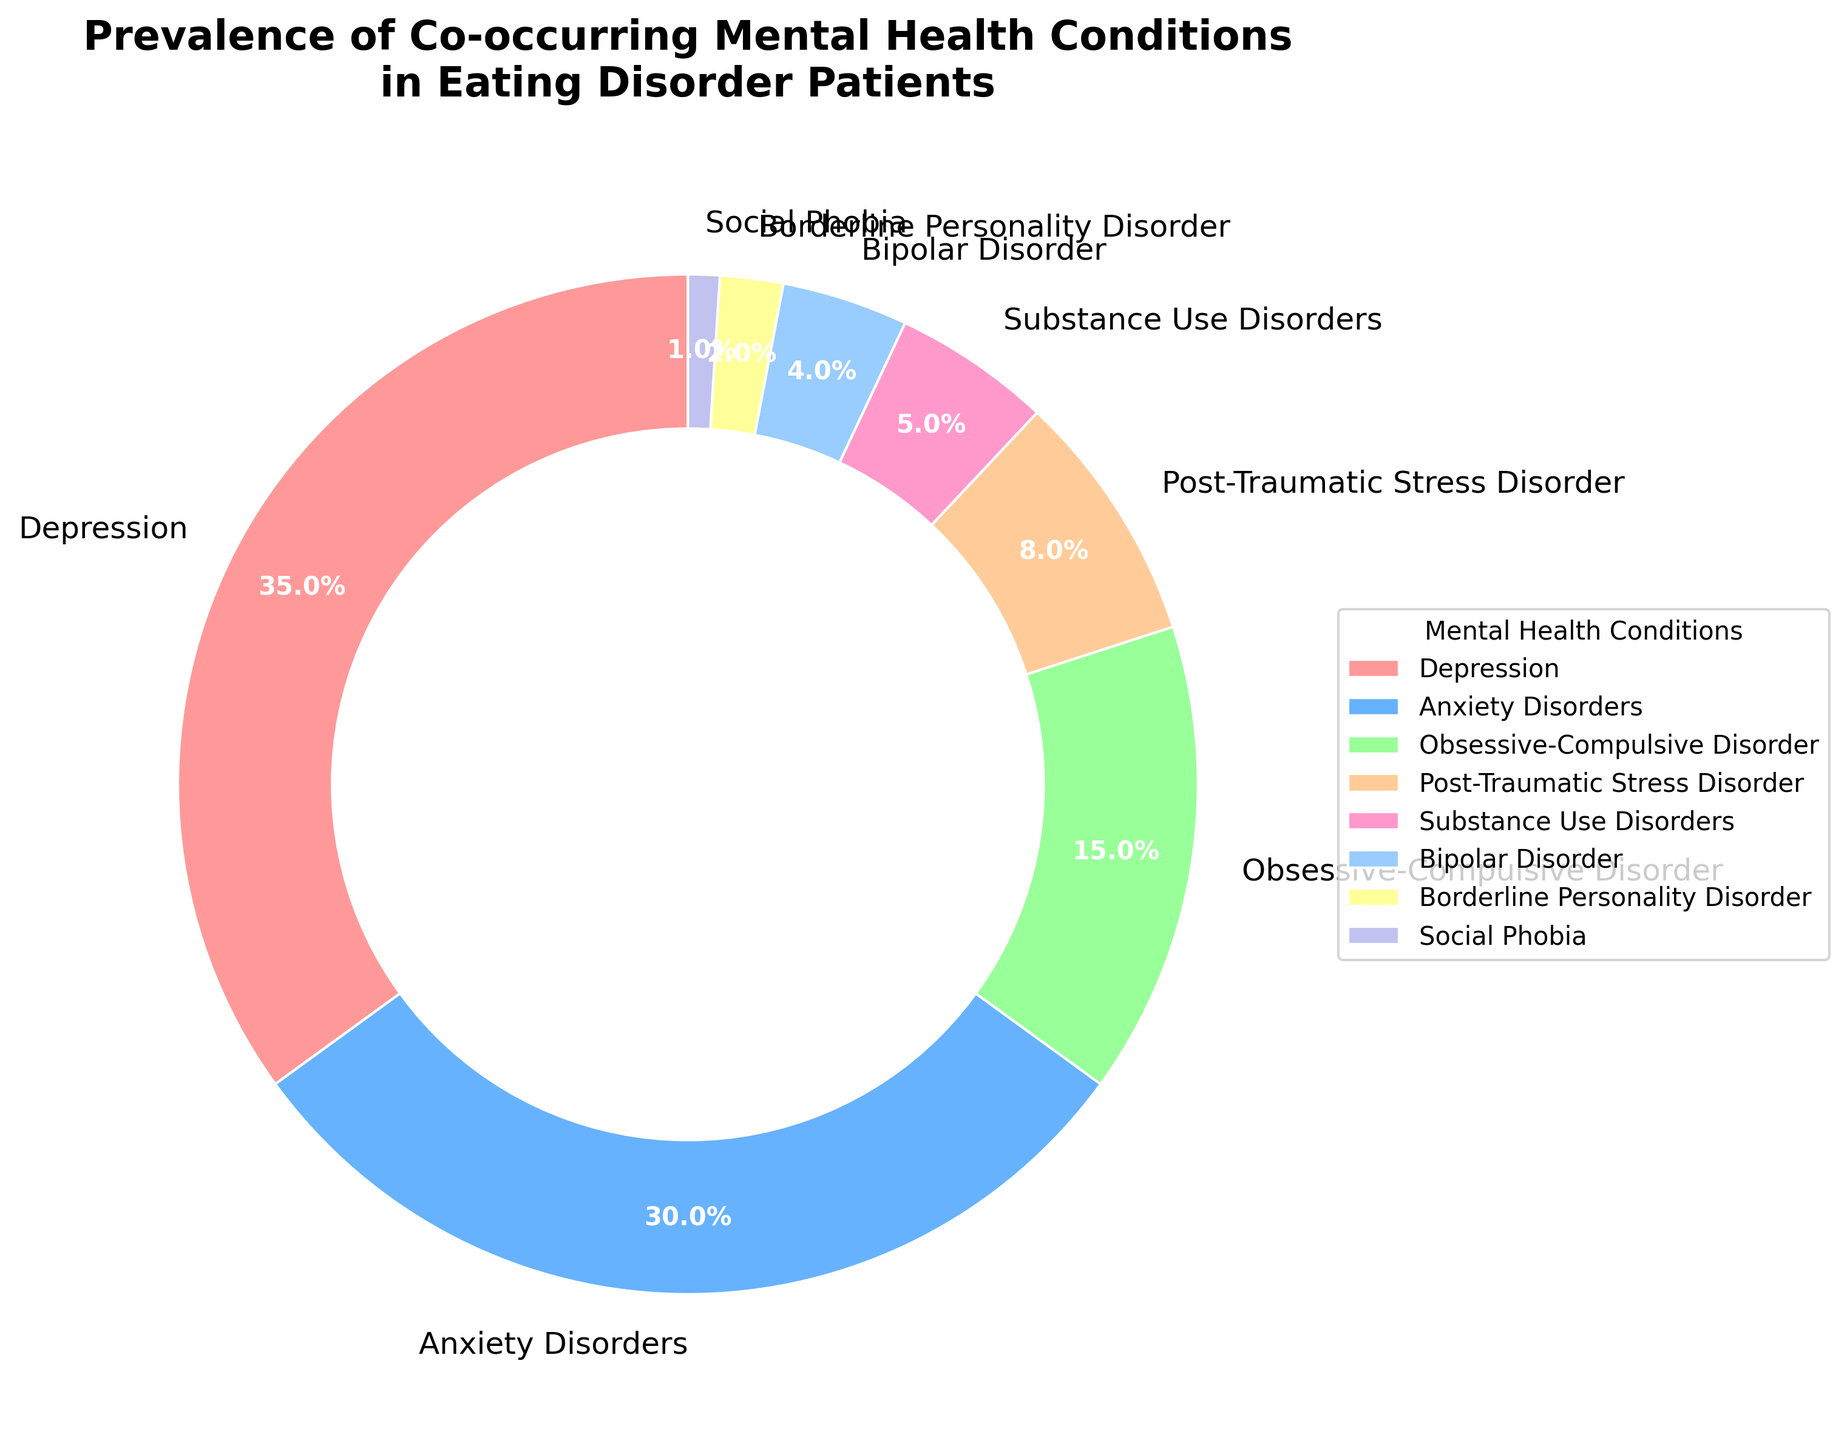What's the most prevalent co-occurring mental health condition among eating disorder patients? The pie chart shows different segments for various mental health conditions. The largest segment represents the most prevalent condition.
Answer: Depression Which mental health disorder has a prevalence percentage twice that of Substance Use Disorders? The pie chart shows various segments with their respective percentages. Substance Use Disorders have a 5% prevalence. A condition with twice this percentage would be 10%. The segment with a 15% prevalence (Obsessive-Compulsive Disorder) is three times, not twice. The closest match is Anxiety Disorders with 30%, but it's not exactly twice 5%.
Answer: None What’s the combined prevalence of Depression and Anxiety Disorders among eating disorder patients? Sum the percentages of Depression (35%) and Anxiety Disorders (30%) by adding them together: 35 + 30.
Answer: 65% Which condition has a prevalence closest to that of Post-Traumatic Stress Disorder? Post-Traumatic Stress Disorder has an 8% prevalence. The closest other percentage in the pie chart is Substance Use Disorders at 5%.
Answer: Substance Use Disorders How does the prevalence of Borderline Personality Disorder compare to Bipolar Disorder? Borderline Personality Disorder has a 2% prevalence, and Bipolar Disorder has a 4% prevalence. Compare the two values: 2 is less than 4.
Answer: Borderline Personality Disorder is less prevalent Out of all conditions listed, which one has the lowest prevalence? Look at the pie chart and identify the smallest segment, which represents the condition with the lowest percentage.
Answer: Social Phobia What’s the combined prevalence of all conditions other than Depression and Anxiety Disorders? Subtract the combined prevalence of Depression (35%) and Anxiety Disorders (30%) from 100%: 100 - 65.
Answer: 35% Which three conditions have a combined prevalence higher than 50%? Sum the prevalence of the top three segments in the pie chart: Depression (35%), Anxiety Disorders (30%), and Obsessive-Compulsive Disorder (15%). The combined sum is 35 + 30 + 15.
Answer: Depression, Anxiety Disorders, Obsessive-Compulsive Disorder What color represents Post-Traumatic Stress Disorder in the pie chart? Observe the color segment that contains the label "Post-Traumatic Stress Disorder" on the pie chart. Post-Traumatic Stress Disorder is colored peach.
Answer: Peach 